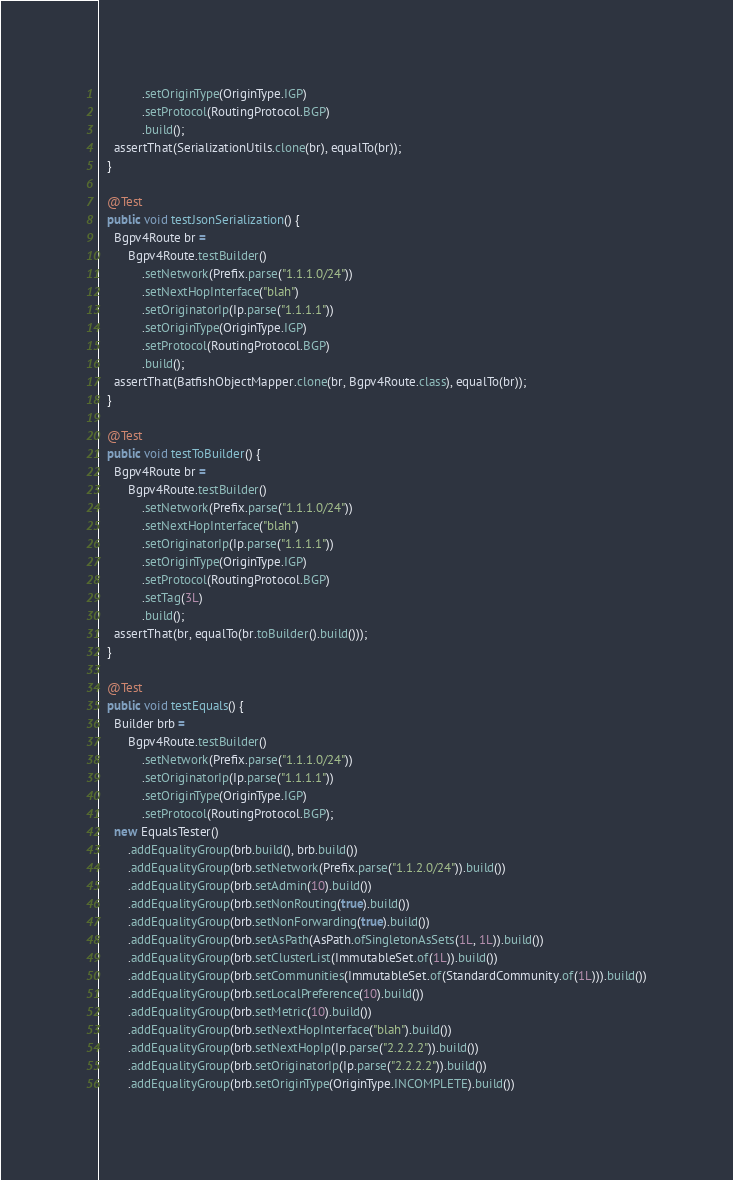Convert code to text. <code><loc_0><loc_0><loc_500><loc_500><_Java_>            .setOriginType(OriginType.IGP)
            .setProtocol(RoutingProtocol.BGP)
            .build();
    assertThat(SerializationUtils.clone(br), equalTo(br));
  }

  @Test
  public void testJsonSerialization() {
    Bgpv4Route br =
        Bgpv4Route.testBuilder()
            .setNetwork(Prefix.parse("1.1.1.0/24"))
            .setNextHopInterface("blah")
            .setOriginatorIp(Ip.parse("1.1.1.1"))
            .setOriginType(OriginType.IGP)
            .setProtocol(RoutingProtocol.BGP)
            .build();
    assertThat(BatfishObjectMapper.clone(br, Bgpv4Route.class), equalTo(br));
  }

  @Test
  public void testToBuilder() {
    Bgpv4Route br =
        Bgpv4Route.testBuilder()
            .setNetwork(Prefix.parse("1.1.1.0/24"))
            .setNextHopInterface("blah")
            .setOriginatorIp(Ip.parse("1.1.1.1"))
            .setOriginType(OriginType.IGP)
            .setProtocol(RoutingProtocol.BGP)
            .setTag(3L)
            .build();
    assertThat(br, equalTo(br.toBuilder().build()));
  }

  @Test
  public void testEquals() {
    Builder brb =
        Bgpv4Route.testBuilder()
            .setNetwork(Prefix.parse("1.1.1.0/24"))
            .setOriginatorIp(Ip.parse("1.1.1.1"))
            .setOriginType(OriginType.IGP)
            .setProtocol(RoutingProtocol.BGP);
    new EqualsTester()
        .addEqualityGroup(brb.build(), brb.build())
        .addEqualityGroup(brb.setNetwork(Prefix.parse("1.1.2.0/24")).build())
        .addEqualityGroup(brb.setAdmin(10).build())
        .addEqualityGroup(brb.setNonRouting(true).build())
        .addEqualityGroup(brb.setNonForwarding(true).build())
        .addEqualityGroup(brb.setAsPath(AsPath.ofSingletonAsSets(1L, 1L)).build())
        .addEqualityGroup(brb.setClusterList(ImmutableSet.of(1L)).build())
        .addEqualityGroup(brb.setCommunities(ImmutableSet.of(StandardCommunity.of(1L))).build())
        .addEqualityGroup(brb.setLocalPreference(10).build())
        .addEqualityGroup(brb.setMetric(10).build())
        .addEqualityGroup(brb.setNextHopInterface("blah").build())
        .addEqualityGroup(brb.setNextHopIp(Ip.parse("2.2.2.2")).build())
        .addEqualityGroup(brb.setOriginatorIp(Ip.parse("2.2.2.2")).build())
        .addEqualityGroup(brb.setOriginType(OriginType.INCOMPLETE).build())</code> 